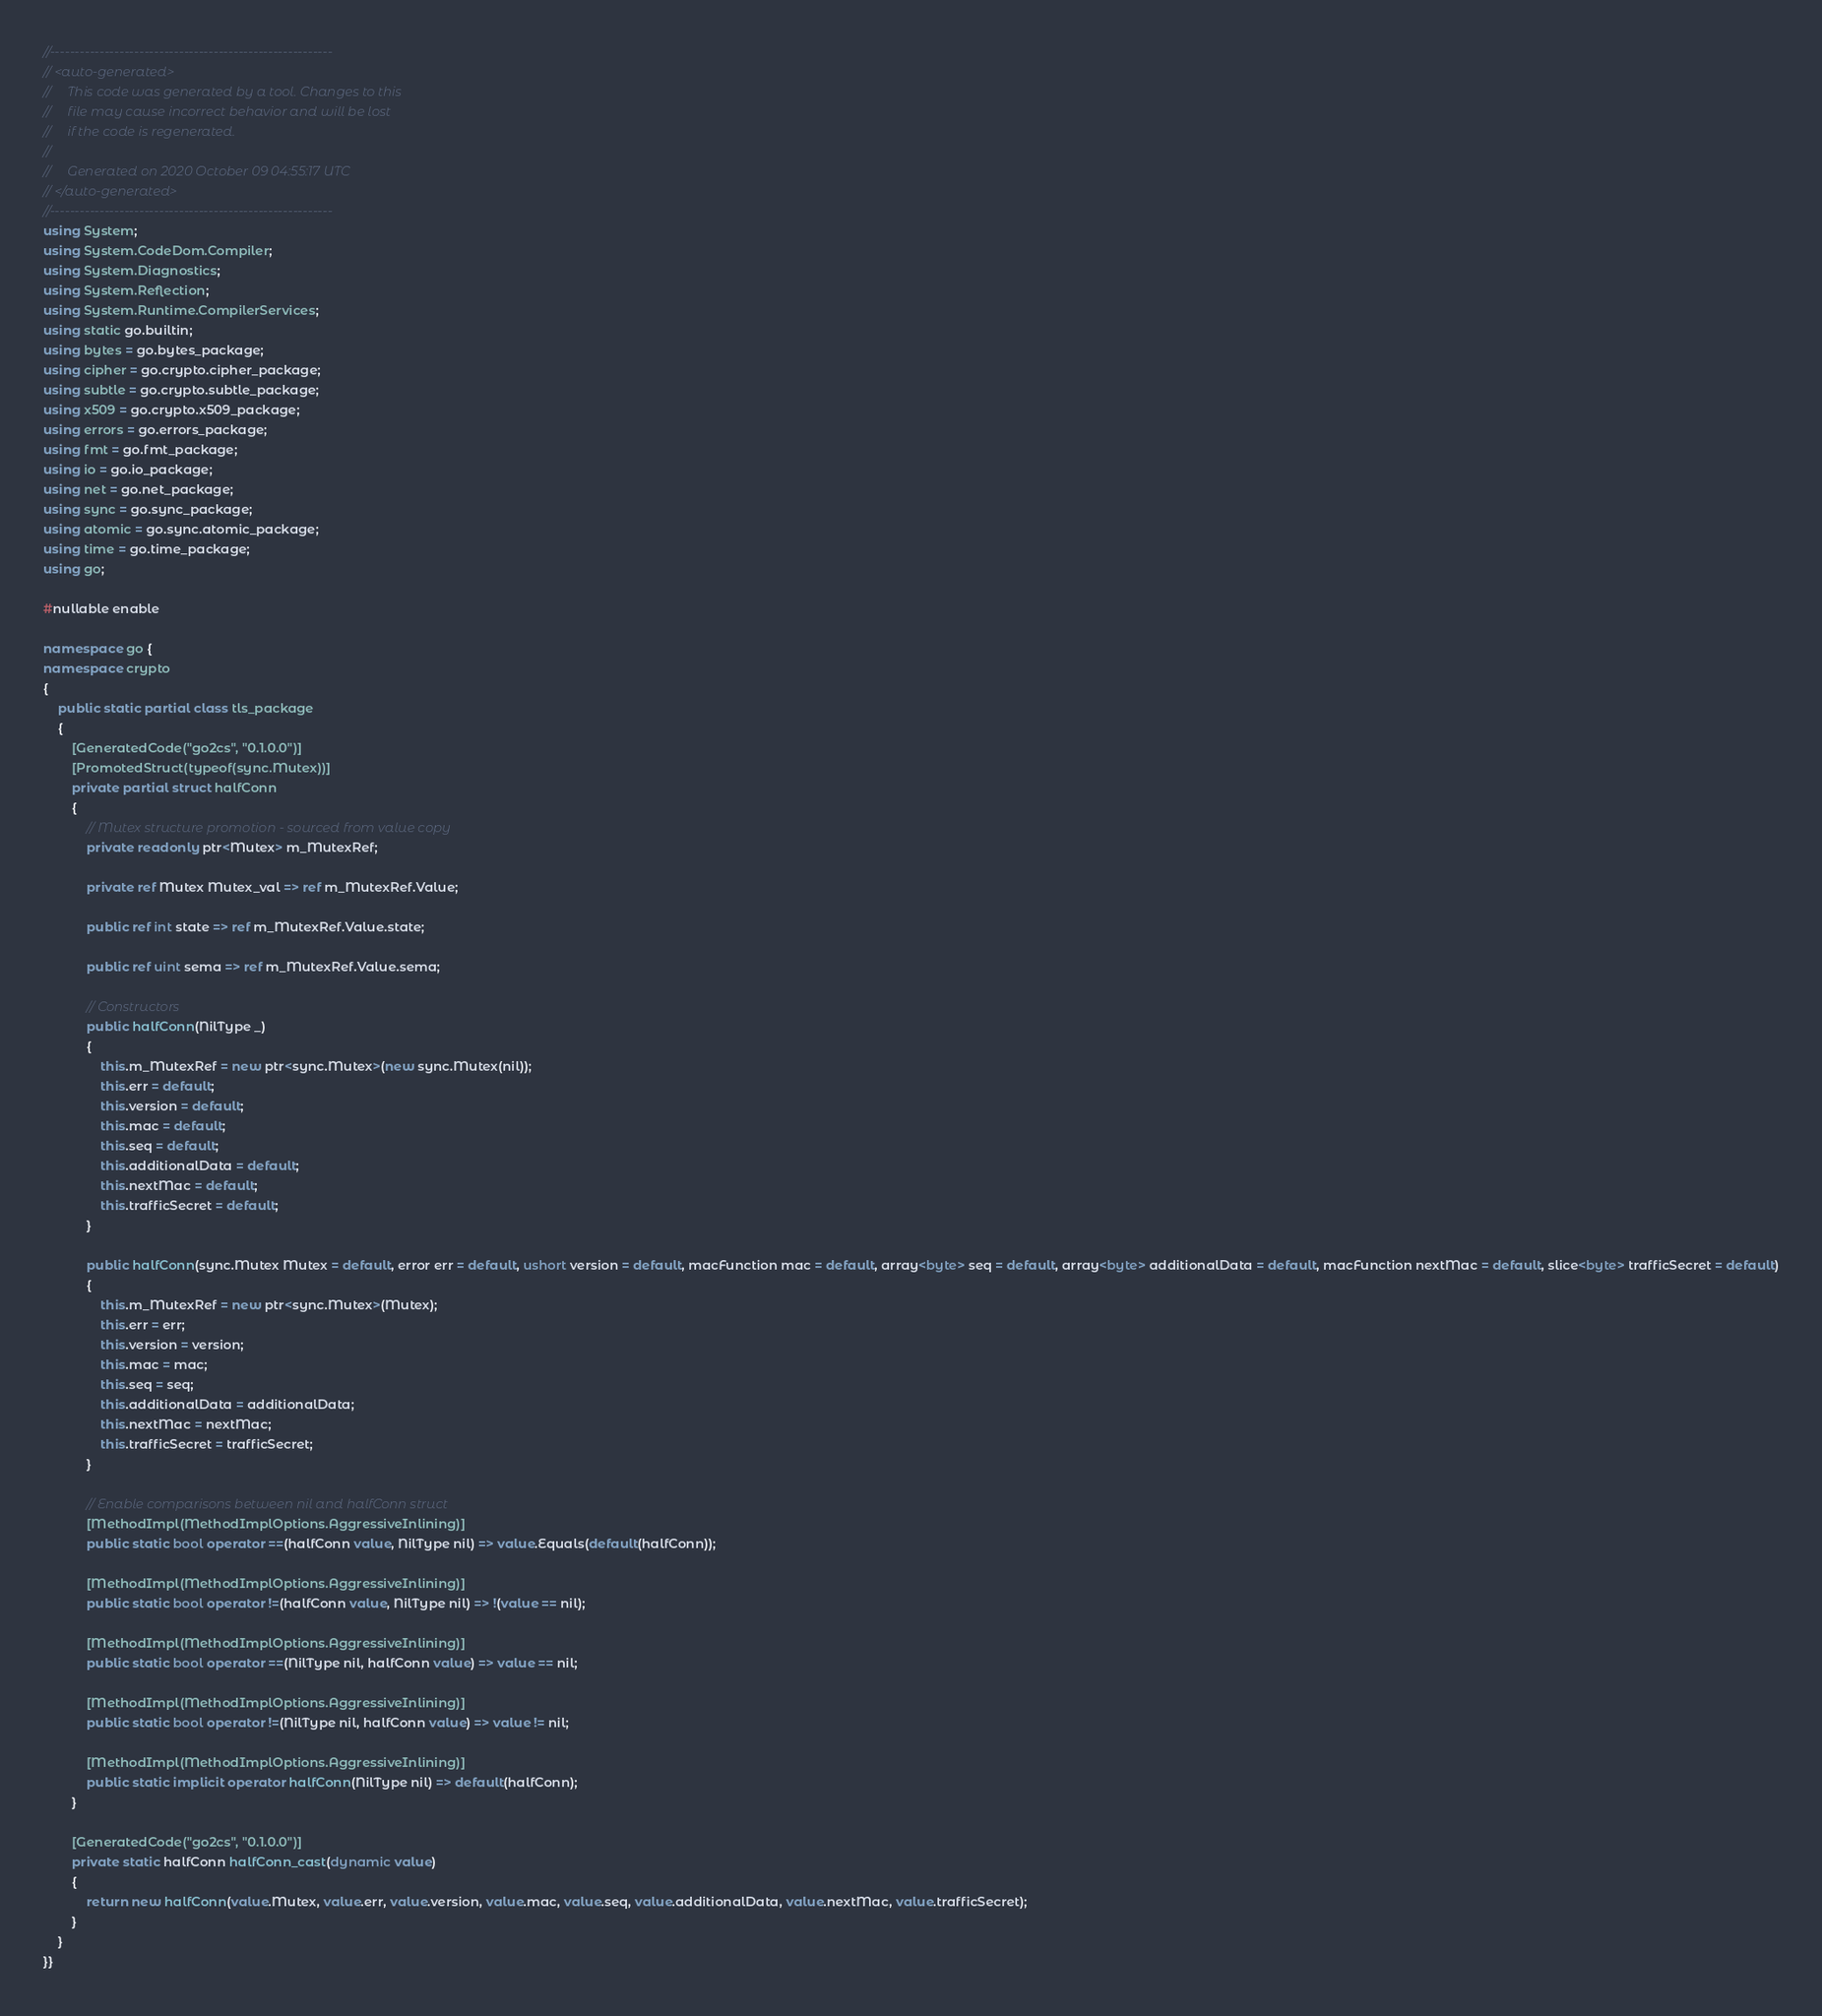Convert code to text. <code><loc_0><loc_0><loc_500><loc_500><_C#_>//---------------------------------------------------------
// <auto-generated>
//     This code was generated by a tool. Changes to this
//     file may cause incorrect behavior and will be lost
//     if the code is regenerated.
//
//     Generated on 2020 October 09 04:55:17 UTC
// </auto-generated>
//---------------------------------------------------------
using System;
using System.CodeDom.Compiler;
using System.Diagnostics;
using System.Reflection;
using System.Runtime.CompilerServices;
using static go.builtin;
using bytes = go.bytes_package;
using cipher = go.crypto.cipher_package;
using subtle = go.crypto.subtle_package;
using x509 = go.crypto.x509_package;
using errors = go.errors_package;
using fmt = go.fmt_package;
using io = go.io_package;
using net = go.net_package;
using sync = go.sync_package;
using atomic = go.sync.atomic_package;
using time = go.time_package;
using go;

#nullable enable

namespace go {
namespace crypto
{
    public static partial class tls_package
    {
        [GeneratedCode("go2cs", "0.1.0.0")]
        [PromotedStruct(typeof(sync.Mutex))]
        private partial struct halfConn
        {
            // Mutex structure promotion - sourced from value copy
            private readonly ptr<Mutex> m_MutexRef;

            private ref Mutex Mutex_val => ref m_MutexRef.Value;

            public ref int state => ref m_MutexRef.Value.state;

            public ref uint sema => ref m_MutexRef.Value.sema;

            // Constructors
            public halfConn(NilType _)
            {
                this.m_MutexRef = new ptr<sync.Mutex>(new sync.Mutex(nil));
                this.err = default;
                this.version = default;
                this.mac = default;
                this.seq = default;
                this.additionalData = default;
                this.nextMac = default;
                this.trafficSecret = default;
            }

            public halfConn(sync.Mutex Mutex = default, error err = default, ushort version = default, macFunction mac = default, array<byte> seq = default, array<byte> additionalData = default, macFunction nextMac = default, slice<byte> trafficSecret = default)
            {
                this.m_MutexRef = new ptr<sync.Mutex>(Mutex);
                this.err = err;
                this.version = version;
                this.mac = mac;
                this.seq = seq;
                this.additionalData = additionalData;
                this.nextMac = nextMac;
                this.trafficSecret = trafficSecret;
            }

            // Enable comparisons between nil and halfConn struct
            [MethodImpl(MethodImplOptions.AggressiveInlining)]
            public static bool operator ==(halfConn value, NilType nil) => value.Equals(default(halfConn));

            [MethodImpl(MethodImplOptions.AggressiveInlining)]
            public static bool operator !=(halfConn value, NilType nil) => !(value == nil);

            [MethodImpl(MethodImplOptions.AggressiveInlining)]
            public static bool operator ==(NilType nil, halfConn value) => value == nil;

            [MethodImpl(MethodImplOptions.AggressiveInlining)]
            public static bool operator !=(NilType nil, halfConn value) => value != nil;

            [MethodImpl(MethodImplOptions.AggressiveInlining)]
            public static implicit operator halfConn(NilType nil) => default(halfConn);
        }

        [GeneratedCode("go2cs", "0.1.0.0")]
        private static halfConn halfConn_cast(dynamic value)
        {
            return new halfConn(value.Mutex, value.err, value.version, value.mac, value.seq, value.additionalData, value.nextMac, value.trafficSecret);
        }
    }
}}</code> 